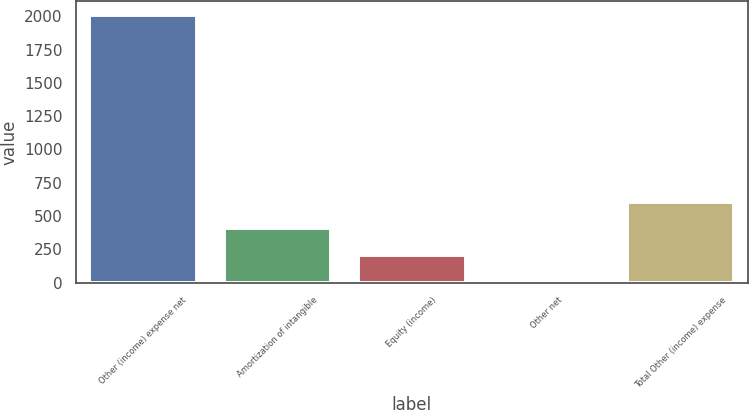<chart> <loc_0><loc_0><loc_500><loc_500><bar_chart><fcel>Other (income) expense net<fcel>Amortization of intangible<fcel>Equity (income)<fcel>Other net<fcel>Total Other (income) expense<nl><fcel>2012<fcel>407.2<fcel>206.6<fcel>6<fcel>607.8<nl></chart> 